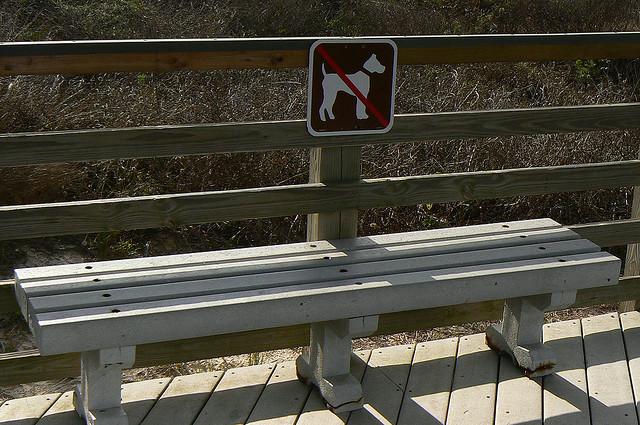Is the bench in the shade?
Keep it brief. Yes. Is this a park?
Short answer required. Yes. What does this sign mean?
Write a very short answer. No dogs. What color is the railing?
Short answer required. Brown. Is there a live dog in the picture?
Write a very short answer. No. 